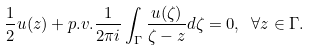<formula> <loc_0><loc_0><loc_500><loc_500>\frac { 1 } { 2 } u ( z ) + p . v . \frac { 1 } { 2 \pi i } \int _ { \Gamma } \frac { u ( \zeta ) } { \zeta - z } d \zeta = 0 , \ \forall z \in \Gamma .</formula> 